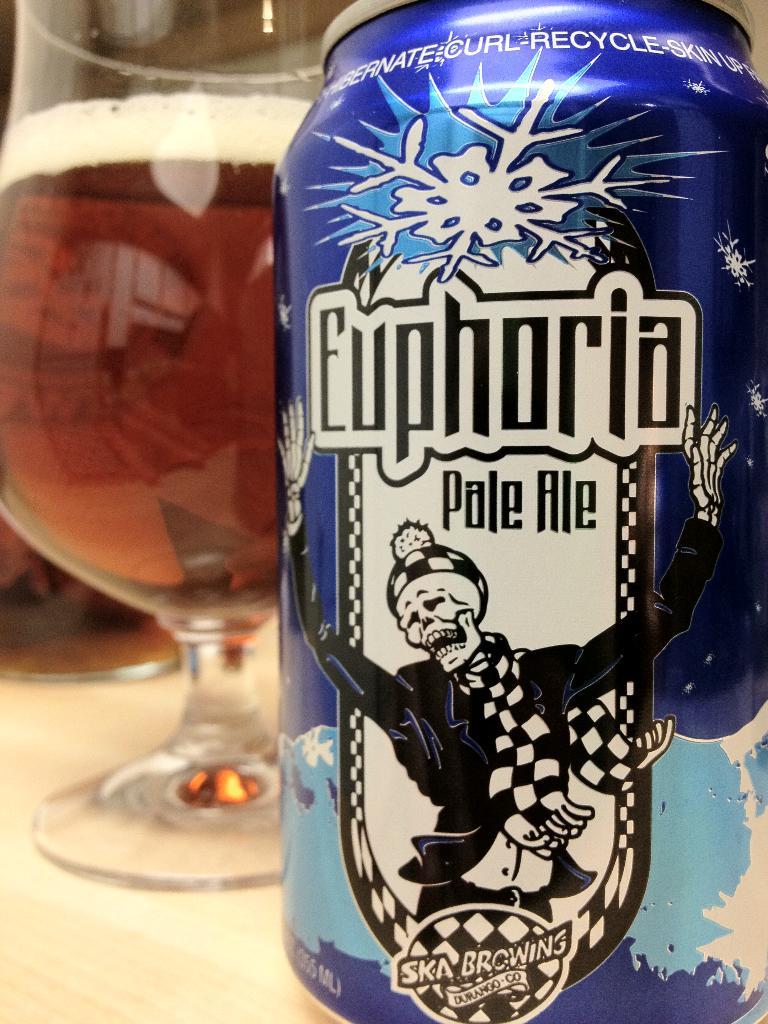What style of beer is in the can?
Make the answer very short. Pale ale. What is the brand name on the can?
Your answer should be compact. Euphoria. 